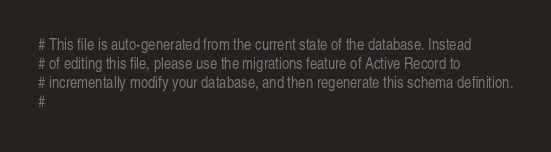<code> <loc_0><loc_0><loc_500><loc_500><_Ruby_># This file is auto-generated from the current state of the database. Instead
# of editing this file, please use the migrations feature of Active Record to
# incrementally modify your database, and then regenerate this schema definition.
#</code> 